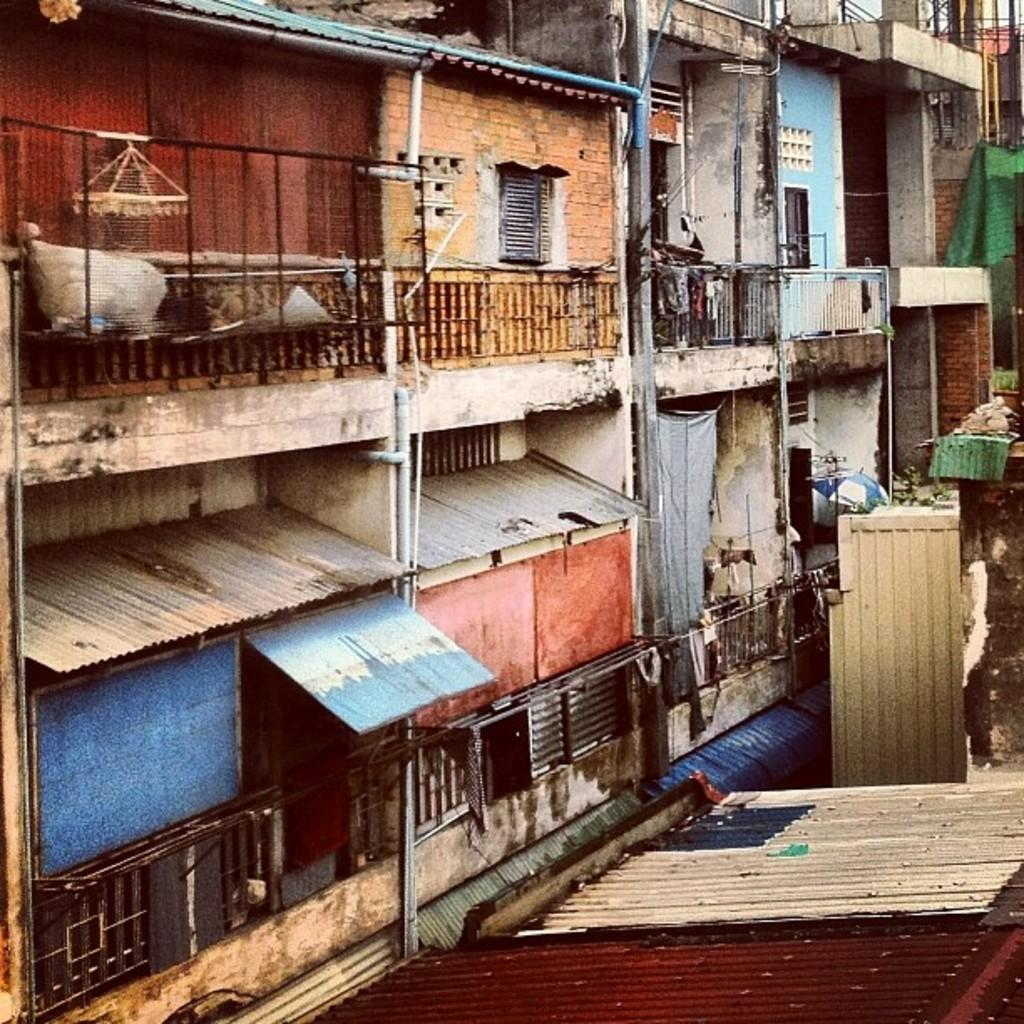What type of structures can be seen in the image? There are buildings in the image. What materials are visible in the image? Pipes, iron sheets, and fencing can be seen in the image. What architectural features are present in the buildings? There are windows in the image. What type of gold jewelry is being worn by the buildings in the image? There is no gold jewelry present in the image; the buildings are made of various materials, including pipes, iron sheets, and fencing. 